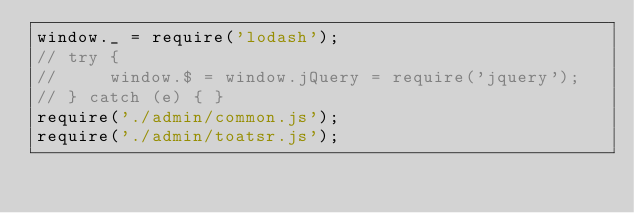Convert code to text. <code><loc_0><loc_0><loc_500><loc_500><_JavaScript_>window._ = require('lodash');
// try {
//     window.$ = window.jQuery = require('jquery');
// } catch (e) { }
require('./admin/common.js');
require('./admin/toatsr.js');




</code> 